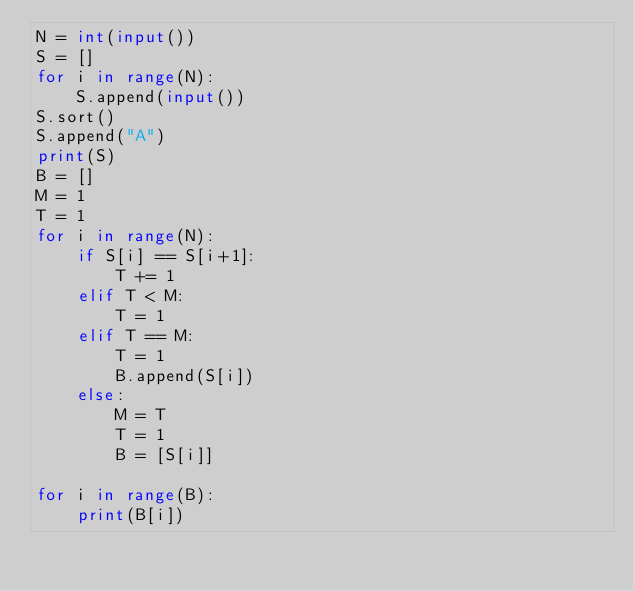Convert code to text. <code><loc_0><loc_0><loc_500><loc_500><_Python_>N = int(input())
S = []
for i in range(N):
    S.append(input())
S.sort()
S.append("A")
print(S)
B = []
M = 1
T = 1
for i in range(N):
    if S[i] == S[i+1]:
        T += 1
    elif T < M:
        T = 1
    elif T == M:
        T = 1
        B.append(S[i])
    else:
        M = T
        T = 1
        B = [S[i]]

for i in range(B):
    print(B[i])</code> 